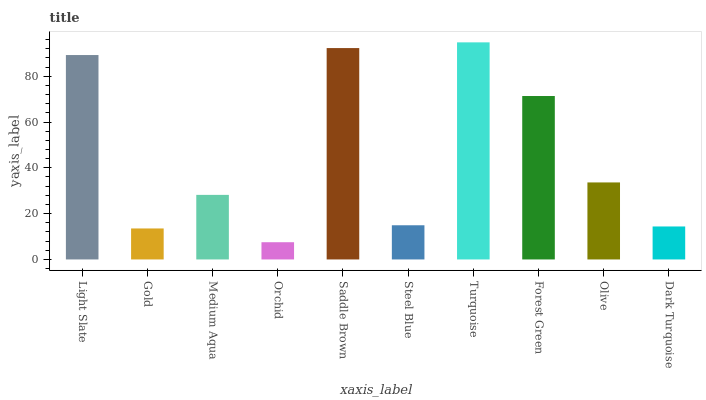Is Orchid the minimum?
Answer yes or no. Yes. Is Turquoise the maximum?
Answer yes or no. Yes. Is Gold the minimum?
Answer yes or no. No. Is Gold the maximum?
Answer yes or no. No. Is Light Slate greater than Gold?
Answer yes or no. Yes. Is Gold less than Light Slate?
Answer yes or no. Yes. Is Gold greater than Light Slate?
Answer yes or no. No. Is Light Slate less than Gold?
Answer yes or no. No. Is Olive the high median?
Answer yes or no. Yes. Is Medium Aqua the low median?
Answer yes or no. Yes. Is Orchid the high median?
Answer yes or no. No. Is Olive the low median?
Answer yes or no. No. 